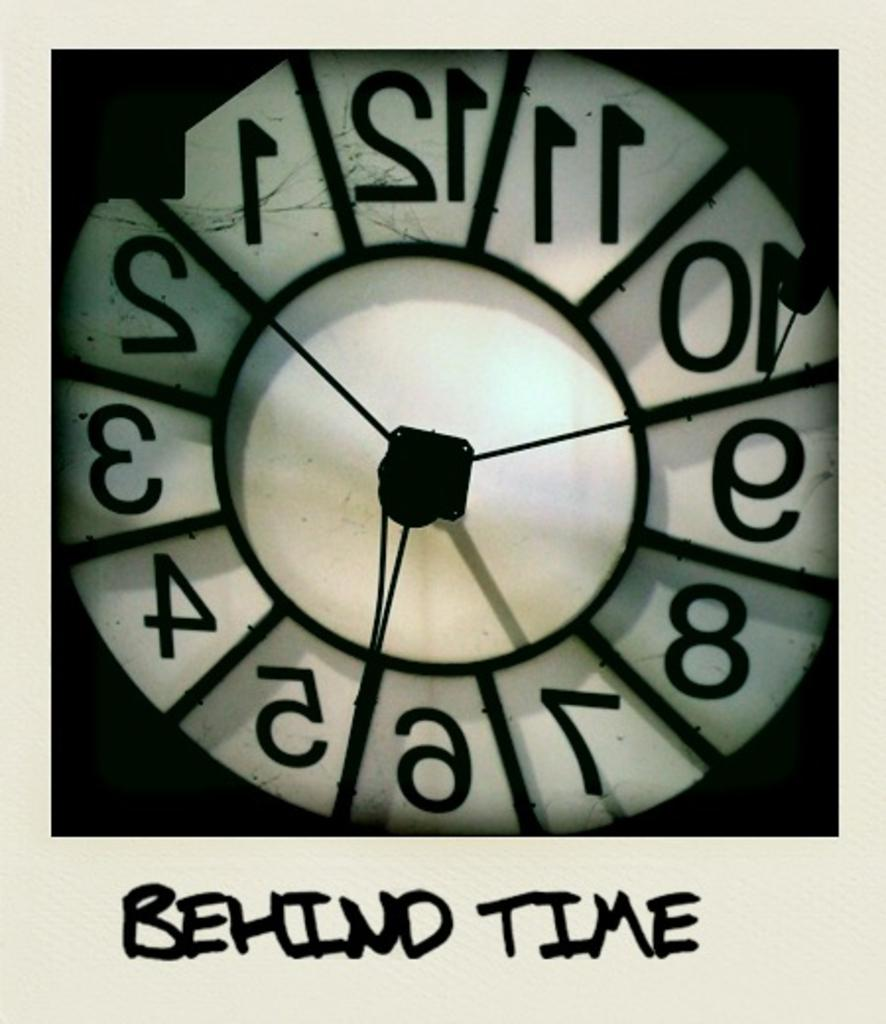<image>
Share a concise interpretation of the image provided. Someone has written "behind time" below a backwards clock. 